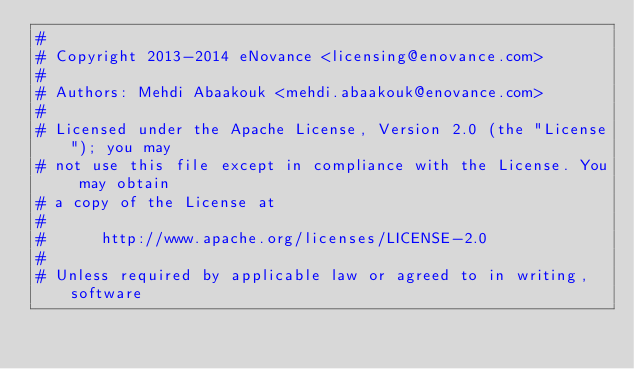Convert code to text. <code><loc_0><loc_0><loc_500><loc_500><_Python_>#
# Copyright 2013-2014 eNovance <licensing@enovance.com>
#
# Authors: Mehdi Abaakouk <mehdi.abaakouk@enovance.com>
#
# Licensed under the Apache License, Version 2.0 (the "License"); you may
# not use this file except in compliance with the License. You may obtain
# a copy of the License at
#
#      http://www.apache.org/licenses/LICENSE-2.0
#
# Unless required by applicable law or agreed to in writing, software</code> 